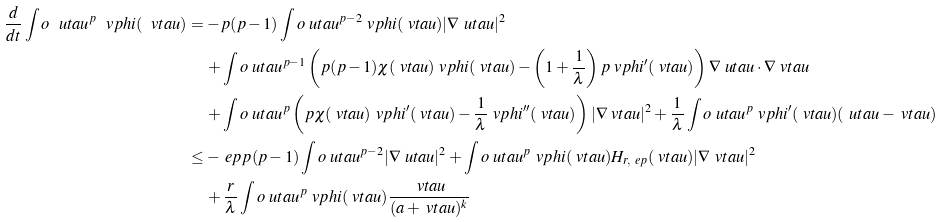<formula> <loc_0><loc_0><loc_500><loc_500>\frac { d } { d t } \int o \ u t a u ^ { p } \ v p h i ( \ v t a u ) & = - p ( p - 1 ) \int o \ u t a u ^ { p - 2 } \ v p h i ( \ v t a u ) | \nabla \ u t a u | ^ { 2 } \\ & \quad \, + \int o \ u t a u ^ { p - 1 } \left ( p ( p - 1 ) \chi ( \ v t a u ) \ v p h i ( \ v t a u ) - \left ( 1 + \frac { 1 } { \lambda } \right ) p \ v p h i ^ { \prime } ( \ v t a u ) \right ) \nabla \ u t a u \cdot \nabla \ v t a u \\ & \quad \, + \int o \ u t a u ^ { p } \left ( p \chi ( \ v t a u ) \ v p h i ^ { \prime } ( \ v t a u ) - \frac { 1 } { \lambda } \ v p h i ^ { \prime \prime } ( \ v t a u ) \right ) | \nabla \ v t a u | ^ { 2 } + \frac { 1 } { \lambda } \int o \ u t a u ^ { p } \ v p h i ^ { \prime } ( \ v t a u ) ( \ u t a u - \ v t a u ) \\ & \leq - \ e p p ( p - 1 ) \int o \ u t a u ^ { p - 2 } | \nabla \ u t a u | ^ { 2 } + \int o \ u t a u ^ { p } \ v p h i ( \ v t a u ) H _ { r , \ e p } ( \ v t a u ) | \nabla \ v t a u | ^ { 2 } \\ & \quad \, + \frac { r } { \lambda } \int o \ u t a u ^ { p } \ v p h i ( \ v t a u ) \frac { \ v t a u } { ( a + \ v t a u ) ^ { k } }</formula> 